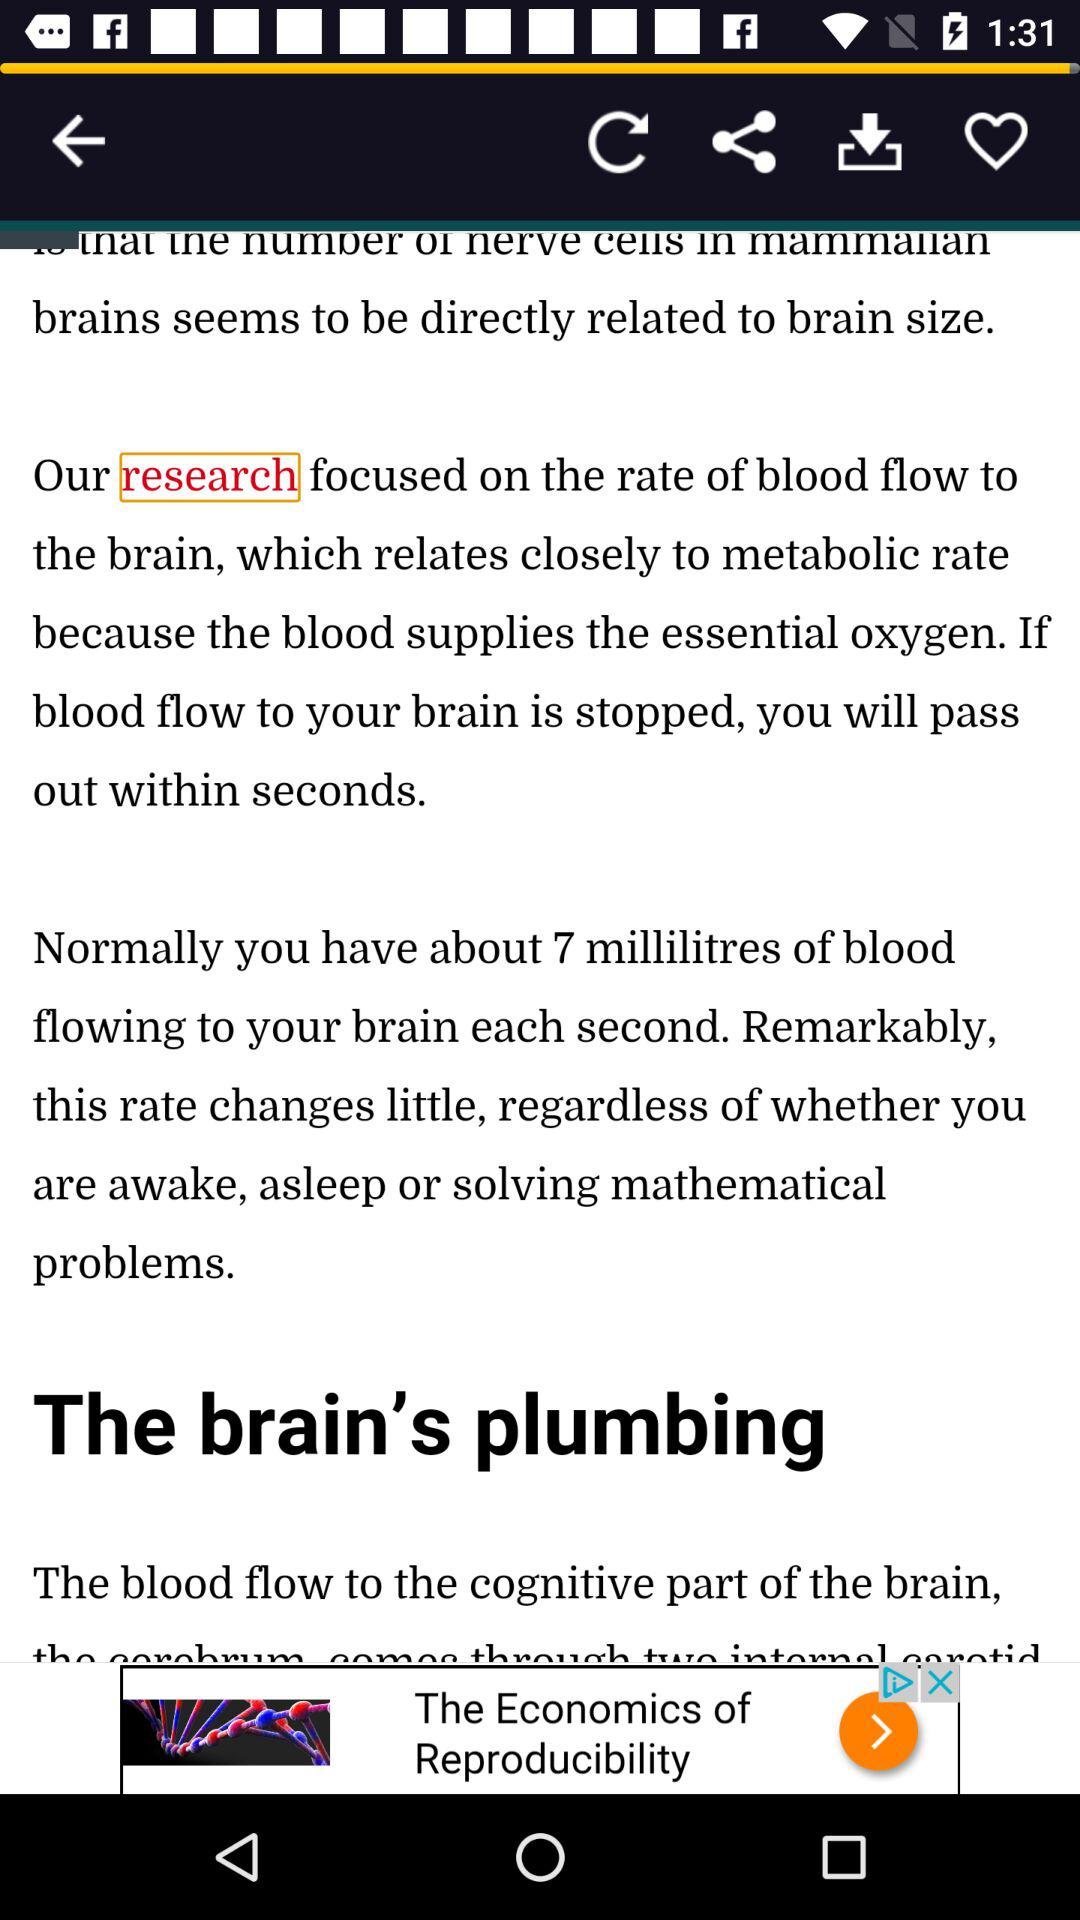How many millilitres of blood flows to the brain each second when you are solving mathematical problems?
Answer the question using a single word or phrase. 7 